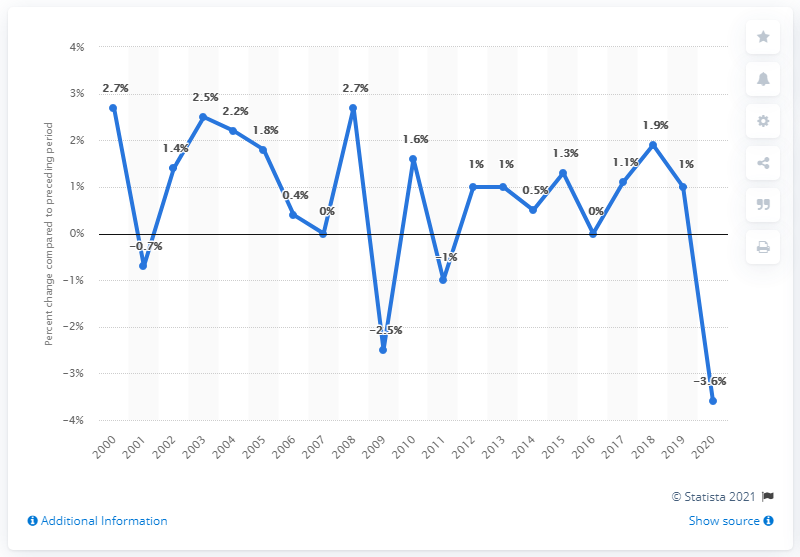Give some essential details in this illustration. In 2008, the Gross Domestic Product (GDP) of Missouri increased by 2.7%. 